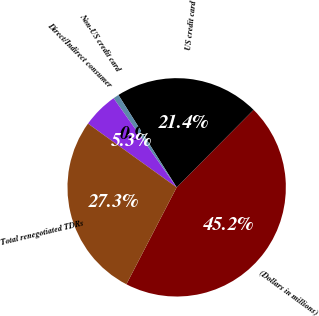Convert chart to OTSL. <chart><loc_0><loc_0><loc_500><loc_500><pie_chart><fcel>(Dollars in millions)<fcel>US credit card<fcel>Non-US credit card<fcel>Direct/Indirect consumer<fcel>Total renegotiated TDRs<nl><fcel>45.17%<fcel>21.39%<fcel>0.85%<fcel>5.28%<fcel>27.3%<nl></chart> 